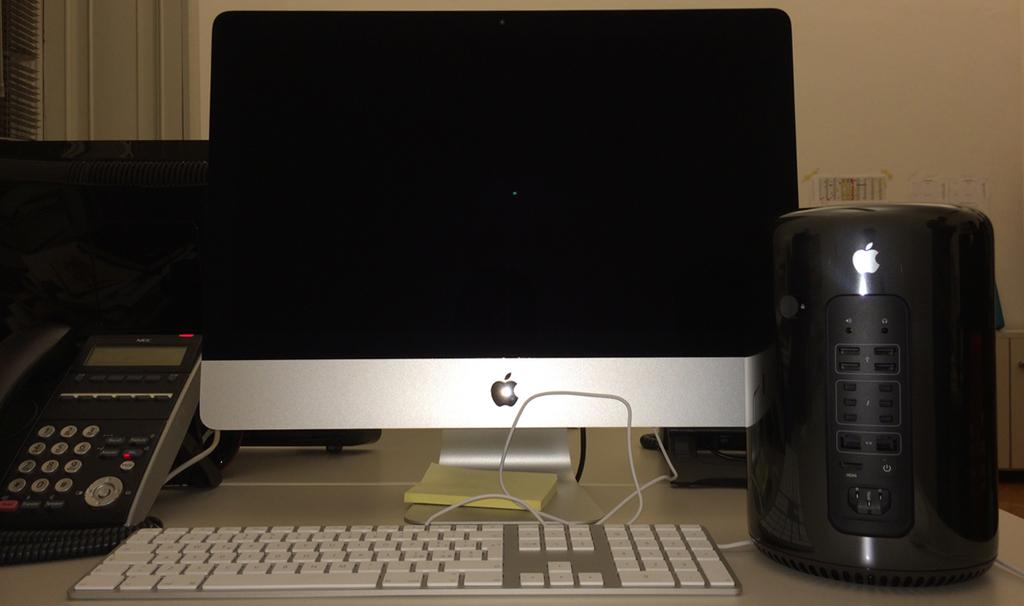What type of device is on the table in the image? There is a telephone on the table. What else can be seen on the table besides the telephone? There is a notepad, a monitor, a keyboard, and an electric machine on the table. What might be used for writing or taking notes in the image? The notepad on the table can be used for writing or taking notes. What is the primary purpose of the electric machine on the table? The specific purpose of the electric machine on the table is not clear from the image, but it may be used for various tasks. What type of farm animals can be seen grazing in the image? There are no farm animals present in the image; it features a table with various devices. What type of liquid is being poured into the electric machine in the image? There is no liquid being poured into the electric machine in the image; it is an electrical device and does not require liquid to function. 